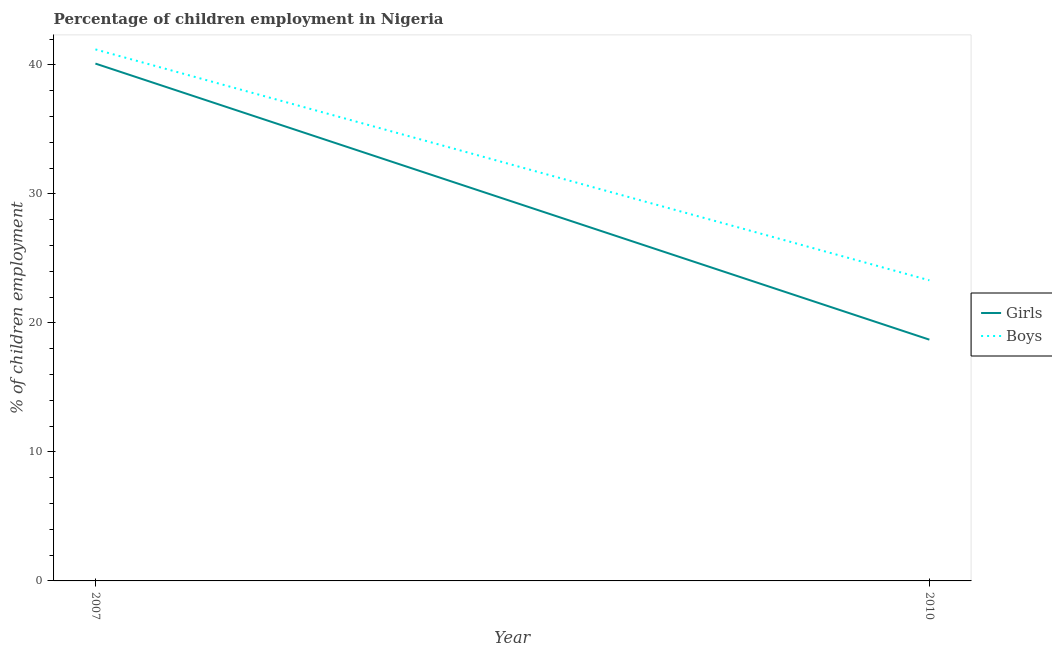Is the number of lines equal to the number of legend labels?
Your answer should be very brief. Yes. What is the percentage of employed boys in 2007?
Offer a very short reply. 41.2. Across all years, what is the maximum percentage of employed boys?
Your answer should be very brief. 41.2. Across all years, what is the minimum percentage of employed boys?
Provide a short and direct response. 23.3. In which year was the percentage of employed girls maximum?
Ensure brevity in your answer.  2007. In which year was the percentage of employed boys minimum?
Offer a very short reply. 2010. What is the total percentage of employed boys in the graph?
Your answer should be compact. 64.5. What is the difference between the percentage of employed boys in 2007 and that in 2010?
Provide a short and direct response. 17.9. What is the average percentage of employed girls per year?
Make the answer very short. 29.4. In the year 2007, what is the difference between the percentage of employed boys and percentage of employed girls?
Offer a very short reply. 1.1. What is the ratio of the percentage of employed girls in 2007 to that in 2010?
Offer a very short reply. 2.14. Is the percentage of employed boys strictly greater than the percentage of employed girls over the years?
Offer a very short reply. Yes. How many lines are there?
Offer a very short reply. 2. How many years are there in the graph?
Your response must be concise. 2. Does the graph contain any zero values?
Keep it short and to the point. No. Does the graph contain grids?
Provide a succinct answer. No. Where does the legend appear in the graph?
Provide a succinct answer. Center right. What is the title of the graph?
Give a very brief answer. Percentage of children employment in Nigeria. What is the label or title of the Y-axis?
Provide a short and direct response. % of children employment. What is the % of children employment in Girls in 2007?
Your answer should be very brief. 40.1. What is the % of children employment in Boys in 2007?
Ensure brevity in your answer.  41.2. What is the % of children employment of Boys in 2010?
Ensure brevity in your answer.  23.3. Across all years, what is the maximum % of children employment of Girls?
Keep it short and to the point. 40.1. Across all years, what is the maximum % of children employment of Boys?
Your response must be concise. 41.2. Across all years, what is the minimum % of children employment of Boys?
Make the answer very short. 23.3. What is the total % of children employment in Girls in the graph?
Offer a very short reply. 58.8. What is the total % of children employment in Boys in the graph?
Ensure brevity in your answer.  64.5. What is the difference between the % of children employment of Girls in 2007 and that in 2010?
Give a very brief answer. 21.4. What is the difference between the % of children employment of Boys in 2007 and that in 2010?
Provide a succinct answer. 17.9. What is the average % of children employment of Girls per year?
Give a very brief answer. 29.4. What is the average % of children employment in Boys per year?
Provide a succinct answer. 32.25. In the year 2007, what is the difference between the % of children employment of Girls and % of children employment of Boys?
Give a very brief answer. -1.1. What is the ratio of the % of children employment of Girls in 2007 to that in 2010?
Make the answer very short. 2.14. What is the ratio of the % of children employment in Boys in 2007 to that in 2010?
Keep it short and to the point. 1.77. What is the difference between the highest and the second highest % of children employment of Girls?
Your answer should be very brief. 21.4. What is the difference between the highest and the second highest % of children employment of Boys?
Provide a short and direct response. 17.9. What is the difference between the highest and the lowest % of children employment in Girls?
Offer a very short reply. 21.4. 